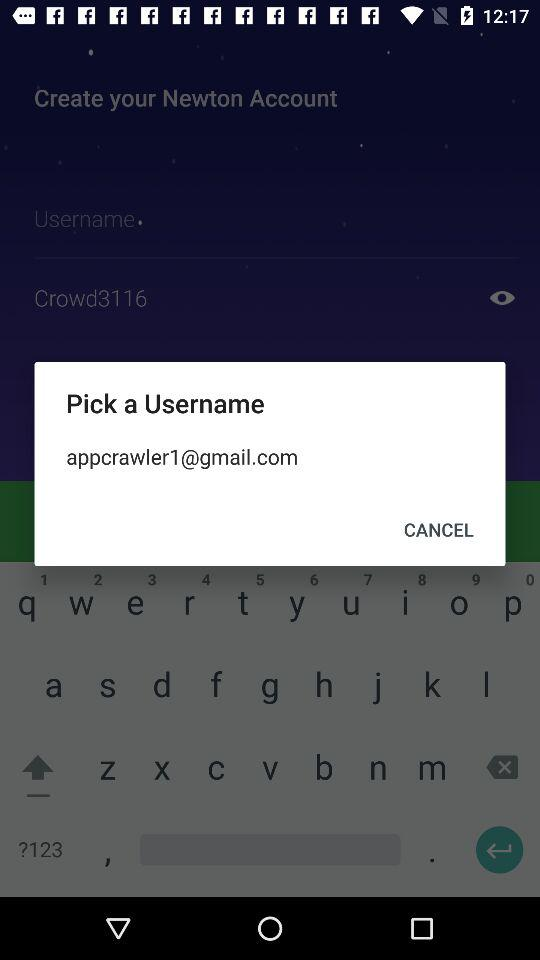What are the options to which email can be added? The options are "GOOGLE APPS", "OFFICE 365", "EXCHANGE", "YAHOO MAIL", "OUTLOOK.COM", "GMAIL", "ICLOUD" and "IMAP". 